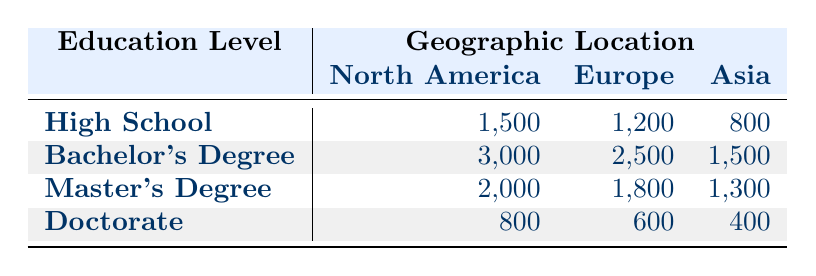What is the number of entrepreneurs with a Bachelor's degree in Europe? The table shows the number of entrepreneurs for different education levels categorized by geographic location. In the "Bachelor's Degree" row and the "Europe" column, the value is 2500.
Answer: 2500 How many entrepreneurs are there in North America with a Master's degree? Looking at the "Master's Degree" row and "North America" column in the table, the corresponding number is 2000.
Answer: 2000 In which geographic location do the highest number of high school graduates become entrepreneurs? The table indicates the number of high school entrepreneurs per geographic location. North America has 1500, Europe has 1200, and Asia has 800. The highest number is in North America.
Answer: North America What is the average number of entrepreneurs with a Doctorate degree across all geographic locations? First, we sum the number of entrepreneurs with a Doctorate: 800 (North America) + 600 (Europe) + 400 (Asia) = 1800. There are 3 locations, so the average is 1800/3 = 600.
Answer: 600 Are there more entrepreneurs with a Bachelor's degree in North America than in Asia? The number of entrepreneurs with a Bachelor's degree in North America is 3000, while in Asia it's 1500. Since 3000 is greater than 1500, the answer is yes.
Answer: Yes Which education level has the least number of entrepreneurs in Asia? In the Asia column, the number of entrepreneurs by education level is: High School (800), Bachelor's Degree (1500), Master's Degree (1300), and Doctorate (400). The least number is in the Doctorate row.
Answer: Doctorate What is the difference in the number of entrepreneurs with a Master's degree between North America and Europe? For Master's Degree, there are 2000 entrepreneurs in North America and 1800 in Europe. The difference is 2000 - 1800 = 200.
Answer: 200 Which region has the lowest total number of entrepreneurs across all education levels? To find the total for each region, sum the values: North America = (1500 + 3000 + 2000 + 800) = 7300, Europe = (1200 + 2500 + 1800 + 600) = 6100, and Asia = (800 + 1500 + 1300 + 400) = 3000. Asia has the lowest total of 3000.
Answer: Asia 